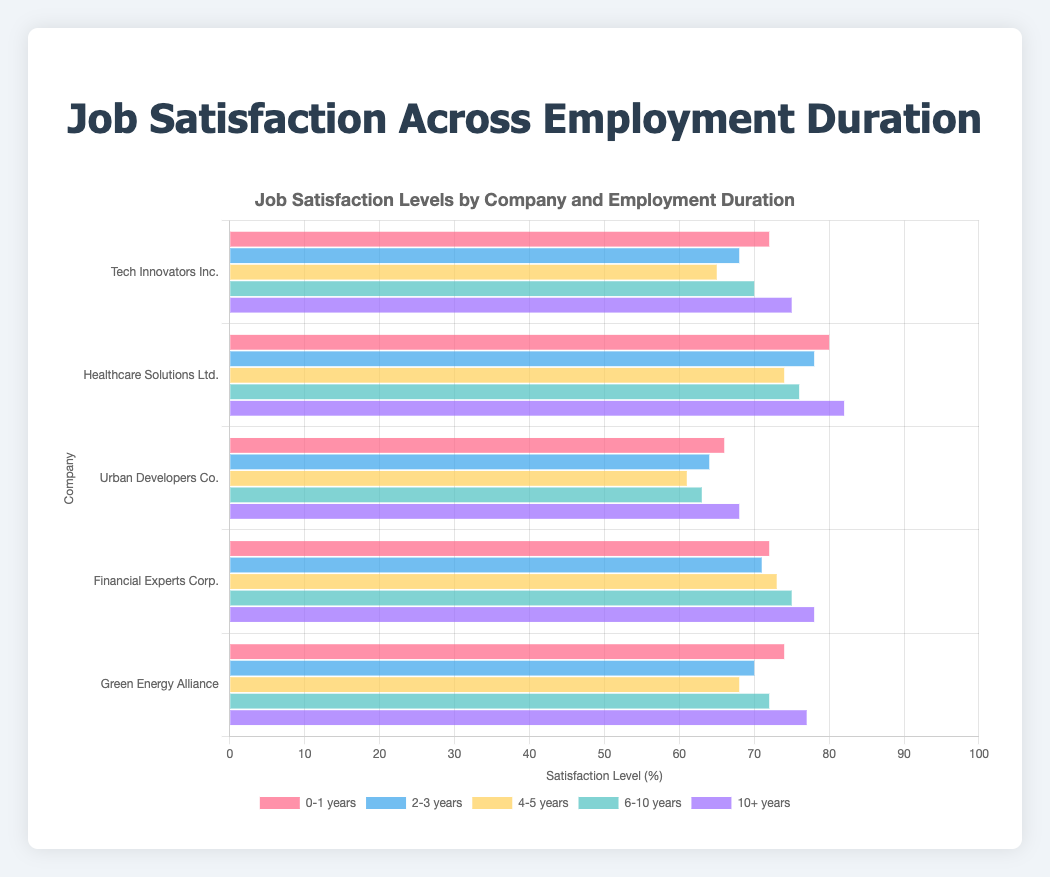What is the highest job satisfaction level for Tech Innovators Inc.? The highest satisfaction level for Tech Innovators Inc. can be observed by looking at the bars representing different lengths of employment. The bar labeled '10+ years' is the longest, indicating a satisfaction level of 75%.
Answer: 75% Which company has the lowest job satisfaction for employees with 4-5 years of employment? To find the lowest job satisfaction for the 4-5 years category, compare the lengths of the bars labeled '4-5 years' across all companies. Urban Developers Co. has the shortest bar, indicating a satisfaction level of 61%.
Answer: Urban Developers Co How does the job satisfaction of Financial Experts Corp. for employees with 6-10 years of employment compare to Green Energy Alliance for the same category? Compare the length of the bar labeled '6-10 years' for both Financial Experts Corp. and Green Energy Alliance. Financial Experts Corp. has a satisfaction level of 75%, while Green Energy Alliance has a satisfaction level of 72%.
Answer: Financial Experts Corp. has higher satisfaction Which company has the highest overall job satisfaction for employees with 0-1 years of employment? Compare the length of the bars labeled '0-1 years' for all companies. Healthcare Solutions Ltd. has the highest bar, indicating a satisfaction level of 80%.
Answer: Healthcare Solutions Ltd What is the average job satisfaction for Urban Developers Co. across all lengths of employment? Calculate the average by summing up the satisfaction levels for Urban Developers Co. (66 + 64 + 61 + 63 + 68) and dividing by the number of data points (5). The sum is 322, so the average is 322 / 5 = 64.4
Answer: 64.4 What is the visual difference between the bars representing '2-3 years' and '10+ years' for Green Energy Alliance? Visually compare the bars for the '2-3 years' and '10+ years' categories by looking at their lengths. The '2-3 years' bar is shorter with a satisfaction level of 70%, while the '10+ years' bar is longer with a satisfaction level of 77%.
Answer: '10+ years' bar is longer How does the job satisfaction trend change over time for Healthcare Solutions Ltd.? Observe the lengths of the bars in order from '0-1 years' to '10+ years'. The trend shows a general increase: 80%, 78%, 74%, 76%, 82%. The overall trend is upward.
Answer: Increasing trend What is the difference in job satisfaction levels for employees with '2-3 years' and '4-5 years' at Tech Innovators Inc.? Subtract the satisfaction level for '4-5 years' from that of '2-3 years'. The values are 68% for '2-3 years' and 65% for '4-5 years'. The difference is 68 - 65 = 3.
Answer: 3% Which company shows the least variation in job satisfaction across different employment durations? Evaluate the variation by looking at the spread of satisfaction levels across different durations for each company. Financial Experts Corp. has satisfaction levels of 72, 71, 73, 75, 78, showing the least variation among companies.
Answer: Financial Experts Corp 